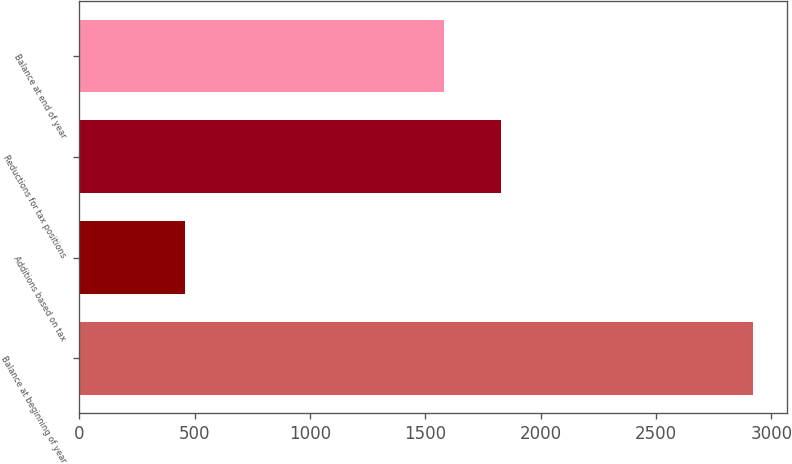Convert chart to OTSL. <chart><loc_0><loc_0><loc_500><loc_500><bar_chart><fcel>Balance at beginning of year<fcel>Additions based on tax<fcel>Reductions for tax positions<fcel>Balance at end of year<nl><fcel>2922<fcel>460<fcel>1829<fcel>1579<nl></chart> 